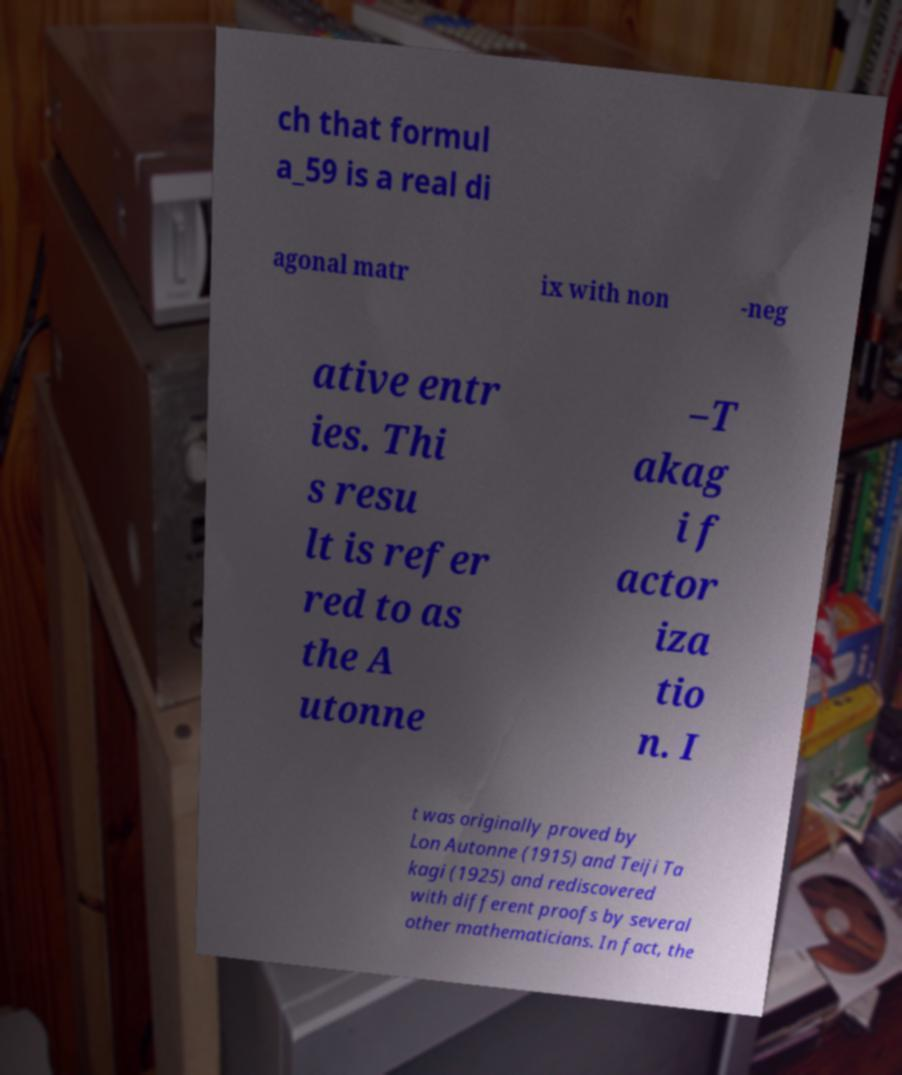What messages or text are displayed in this image? I need them in a readable, typed format. ch that formul a_59 is a real di agonal matr ix with non -neg ative entr ies. Thi s resu lt is refer red to as the A utonne –T akag i f actor iza tio n. I t was originally proved by Lon Autonne (1915) and Teiji Ta kagi (1925) and rediscovered with different proofs by several other mathematicians. In fact, the 